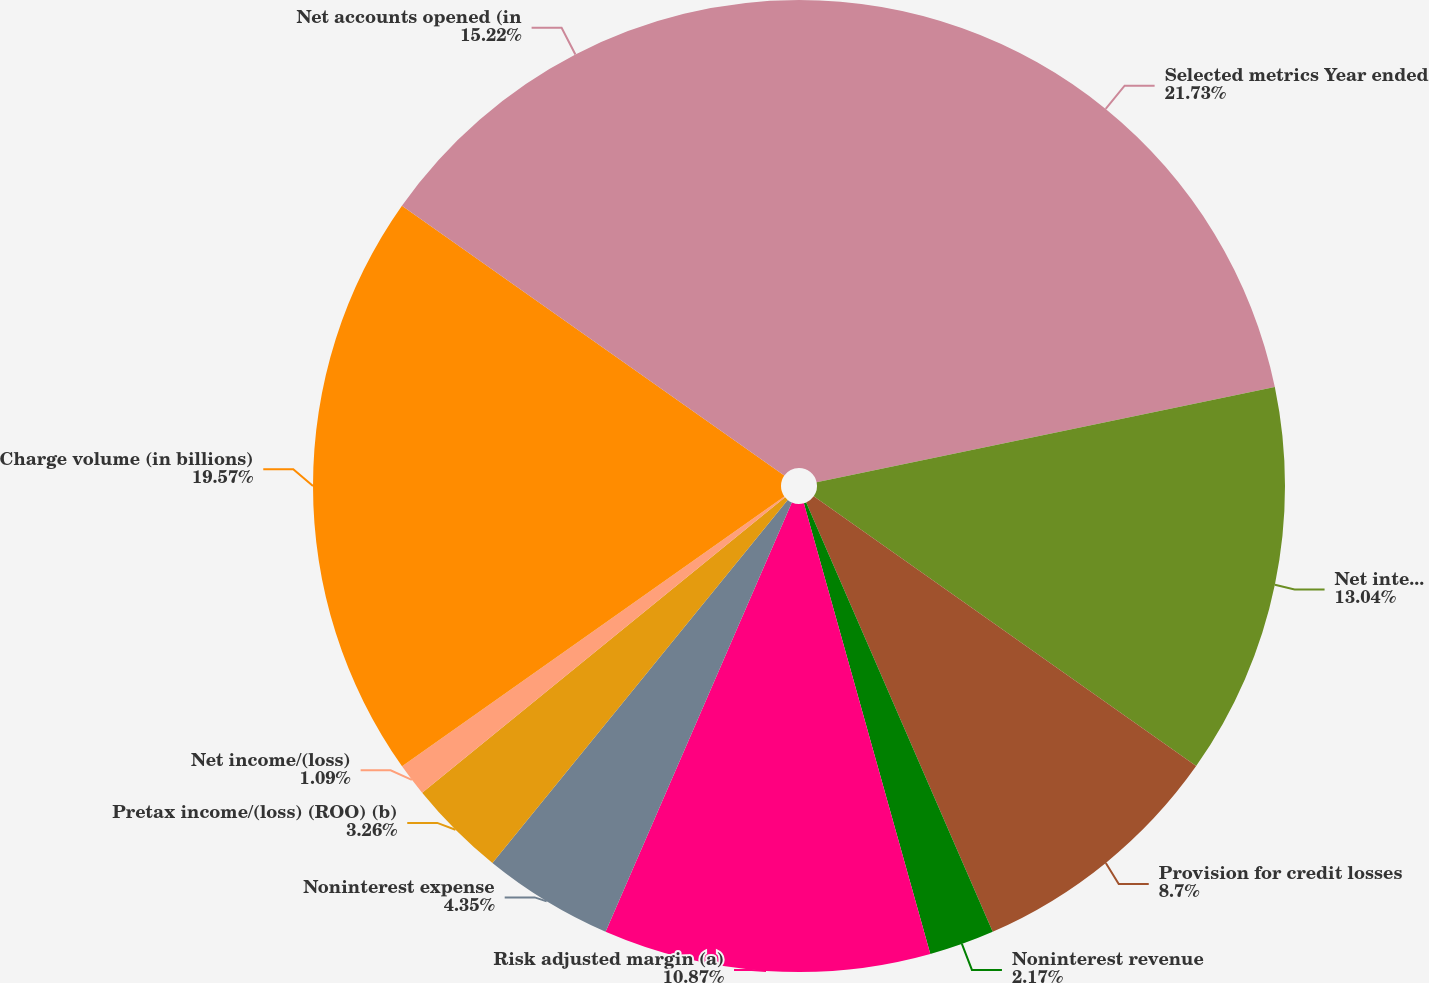Convert chart. <chart><loc_0><loc_0><loc_500><loc_500><pie_chart><fcel>Selected metrics Year ended<fcel>Net interest income<fcel>Provision for credit losses<fcel>Noninterest revenue<fcel>Risk adjusted margin (a)<fcel>Noninterest expense<fcel>Pretax income/(loss) (ROO) (b)<fcel>Net income/(loss)<fcel>Charge volume (in billions)<fcel>Net accounts opened (in<nl><fcel>21.74%<fcel>13.04%<fcel>8.7%<fcel>2.17%<fcel>10.87%<fcel>4.35%<fcel>3.26%<fcel>1.09%<fcel>19.57%<fcel>15.22%<nl></chart> 